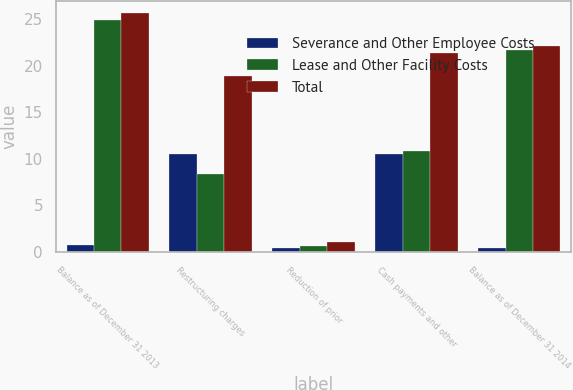<chart> <loc_0><loc_0><loc_500><loc_500><stacked_bar_chart><ecel><fcel>Balance as of December 31 2013<fcel>Restructuring charges<fcel>Reduction of prior<fcel>Cash payments and other<fcel>Balance as of December 31 2014<nl><fcel>Severance and Other Employee Costs<fcel>0.8<fcel>10.5<fcel>0.4<fcel>10.5<fcel>0.4<nl><fcel>Lease and Other Facility Costs<fcel>24.9<fcel>8.4<fcel>0.7<fcel>10.9<fcel>21.7<nl><fcel>Total<fcel>25.7<fcel>18.9<fcel>1.1<fcel>21.4<fcel>22.1<nl></chart> 